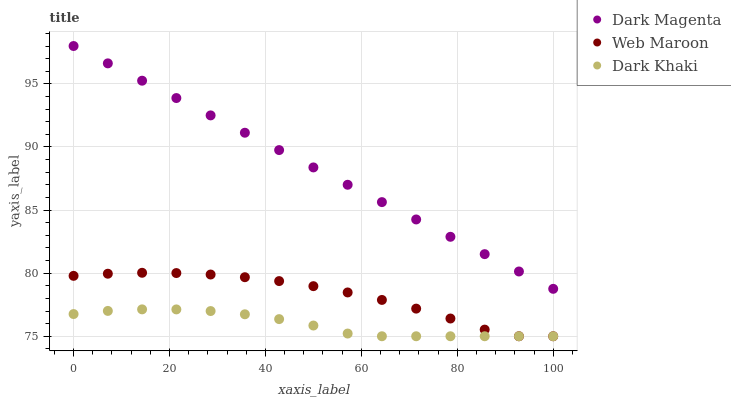Does Dark Khaki have the minimum area under the curve?
Answer yes or no. Yes. Does Dark Magenta have the maximum area under the curve?
Answer yes or no. Yes. Does Web Maroon have the minimum area under the curve?
Answer yes or no. No. Does Web Maroon have the maximum area under the curve?
Answer yes or no. No. Is Dark Magenta the smoothest?
Answer yes or no. Yes. Is Web Maroon the roughest?
Answer yes or no. Yes. Is Web Maroon the smoothest?
Answer yes or no. No. Is Dark Magenta the roughest?
Answer yes or no. No. Does Dark Khaki have the lowest value?
Answer yes or no. Yes. Does Dark Magenta have the lowest value?
Answer yes or no. No. Does Dark Magenta have the highest value?
Answer yes or no. Yes. Does Web Maroon have the highest value?
Answer yes or no. No. Is Dark Khaki less than Dark Magenta?
Answer yes or no. Yes. Is Dark Magenta greater than Web Maroon?
Answer yes or no. Yes. Does Dark Khaki intersect Web Maroon?
Answer yes or no. Yes. Is Dark Khaki less than Web Maroon?
Answer yes or no. No. Is Dark Khaki greater than Web Maroon?
Answer yes or no. No. Does Dark Khaki intersect Dark Magenta?
Answer yes or no. No. 